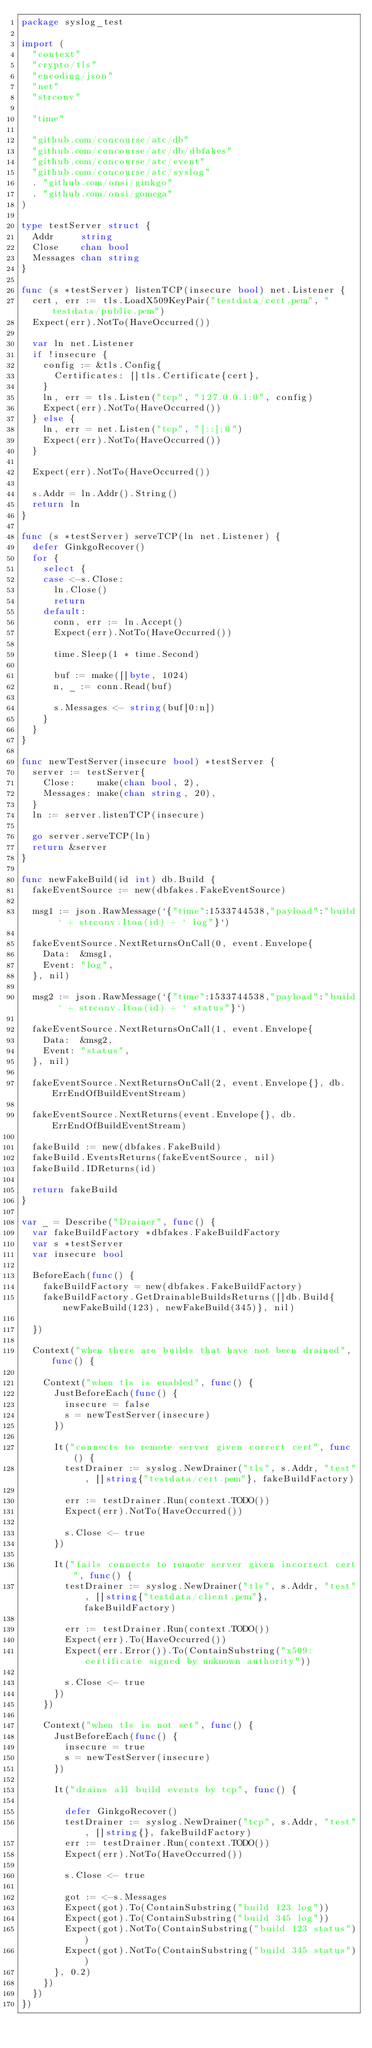Convert code to text. <code><loc_0><loc_0><loc_500><loc_500><_Go_>package syslog_test

import (
	"context"
	"crypto/tls"
	"encoding/json"
	"net"
	"strconv"

	"time"

	"github.com/concourse/atc/db"
	"github.com/concourse/atc/db/dbfakes"
	"github.com/concourse/atc/event"
	"github.com/concourse/atc/syslog"
	. "github.com/onsi/ginkgo"
	. "github.com/onsi/gomega"
)

type testServer struct {
	Addr     string
	Close    chan bool
	Messages chan string
}

func (s *testServer) listenTCP(insecure bool) net.Listener {
	cert, err := tls.LoadX509KeyPair("testdata/cert.pem", "testdata/public.pem")
	Expect(err).NotTo(HaveOccurred())

	var ln net.Listener
	if !insecure {
		config := &tls.Config{
			Certificates: []tls.Certificate{cert},
		}
		ln, err = tls.Listen("tcp", "127.0.0.1:0", config)
		Expect(err).NotTo(HaveOccurred())
	} else {
		ln, err = net.Listen("tcp", "[::]:0")
		Expect(err).NotTo(HaveOccurred())
	}

	Expect(err).NotTo(HaveOccurred())

	s.Addr = ln.Addr().String()
	return ln
}

func (s *testServer) serveTCP(ln net.Listener) {
	defer GinkgoRecover()
	for {
		select {
		case <-s.Close:
			ln.Close()
			return
		default:
			conn, err := ln.Accept()
			Expect(err).NotTo(HaveOccurred())

			time.Sleep(1 * time.Second)

			buf := make([]byte, 1024)
			n, _ := conn.Read(buf)

			s.Messages <- string(buf[0:n])
		}
	}
}

func newTestServer(insecure bool) *testServer {
	server := testServer{
		Close:    make(chan bool, 2),
		Messages: make(chan string, 20),
	}
	ln := server.listenTCP(insecure)

	go server.serveTCP(ln)
	return &server
}

func newFakeBuild(id int) db.Build {
	fakeEventSource := new(dbfakes.FakeEventSource)

	msg1 := json.RawMessage(`{"time":1533744538,"payload":"build ` + strconv.Itoa(id) + ` log"}`)

	fakeEventSource.NextReturnsOnCall(0, event.Envelope{
		Data:  &msg1,
		Event: "log",
	}, nil)

	msg2 := json.RawMessage(`{"time":1533744538,"payload":"build ` + strconv.Itoa(id) + ` status"}`)

	fakeEventSource.NextReturnsOnCall(1, event.Envelope{
		Data:  &msg2,
		Event: "status",
	}, nil)

	fakeEventSource.NextReturnsOnCall(2, event.Envelope{}, db.ErrEndOfBuildEventStream)

	fakeEventSource.NextReturns(event.Envelope{}, db.ErrEndOfBuildEventStream)

	fakeBuild := new(dbfakes.FakeBuild)
	fakeBuild.EventsReturns(fakeEventSource, nil)
	fakeBuild.IDReturns(id)

	return fakeBuild
}

var _ = Describe("Drainer", func() {
	var fakeBuildFactory *dbfakes.FakeBuildFactory
	var s *testServer
	var insecure bool

	BeforeEach(func() {
		fakeBuildFactory = new(dbfakes.FakeBuildFactory)
		fakeBuildFactory.GetDrainableBuildsReturns([]db.Build{newFakeBuild(123), newFakeBuild(345)}, nil)

	})

	Context("when there are builds that have not been drained", func() {

		Context("when tls is enabled", func() {
			JustBeforeEach(func() {
				insecure = false
				s = newTestServer(insecure)
			})

			It("connects to remote server given correct cert", func() {
				testDrainer := syslog.NewDrainer("tls", s.Addr, "test", []string{"testdata/cert.pem"}, fakeBuildFactory)

				err := testDrainer.Run(context.TODO())
				Expect(err).NotTo(HaveOccurred())

				s.Close <- true
			})

			It("fails connects to remote server given incorrect cert", func() {
				testDrainer := syslog.NewDrainer("tls", s.Addr, "test", []string{"testdata/client.pem"}, fakeBuildFactory)

				err := testDrainer.Run(context.TODO())
				Expect(err).To(HaveOccurred())
				Expect(err.Error()).To(ContainSubstring("x509: certificate signed by unknown authority"))

				s.Close <- true
			})
		})

		Context("when tls is not set", func() {
			JustBeforeEach(func() {
				insecure = true
				s = newTestServer(insecure)
			})

			It("drains all build events by tcp", func() {

				defer GinkgoRecover()
				testDrainer := syslog.NewDrainer("tcp", s.Addr, "test", []string{}, fakeBuildFactory)
				err := testDrainer.Run(context.TODO())
				Expect(err).NotTo(HaveOccurred())

				s.Close <- true

				got := <-s.Messages
				Expect(got).To(ContainSubstring("build 123 log"))
				Expect(got).To(ContainSubstring("build 345 log"))
				Expect(got).NotTo(ContainSubstring("build 123 status"))
				Expect(got).NotTo(ContainSubstring("build 345 status"))
			}, 0.2)
		})
	})
})
</code> 